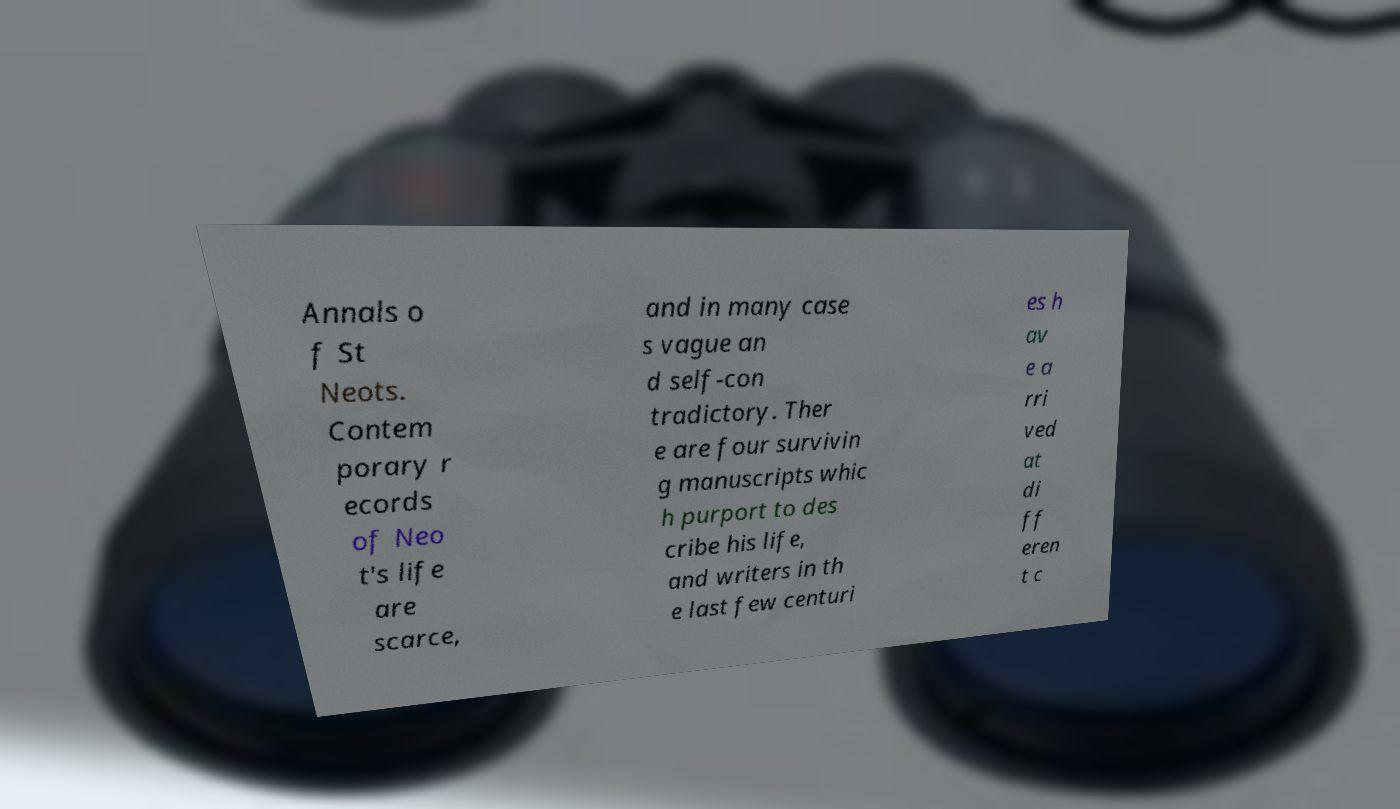Can you accurately transcribe the text from the provided image for me? Annals o f St Neots. Contem porary r ecords of Neo t's life are scarce, and in many case s vague an d self-con tradictory. Ther e are four survivin g manuscripts whic h purport to des cribe his life, and writers in th e last few centuri es h av e a rri ved at di ff eren t c 